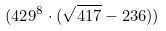Convert formula to latex. <formula><loc_0><loc_0><loc_500><loc_500>( 4 2 9 ^ { 8 } \cdot ( \sqrt { 4 1 7 } - 2 3 6 ) )</formula> 